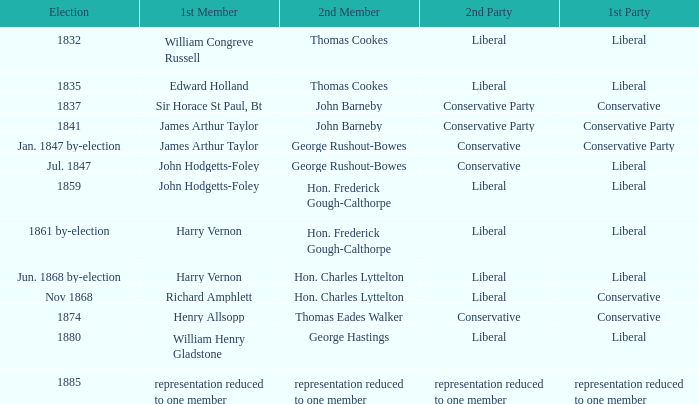What was the second party, when the initial member was john hodgetts-foley, and the subsequent member was hon. frederick gough-calthorpe? Liberal. 